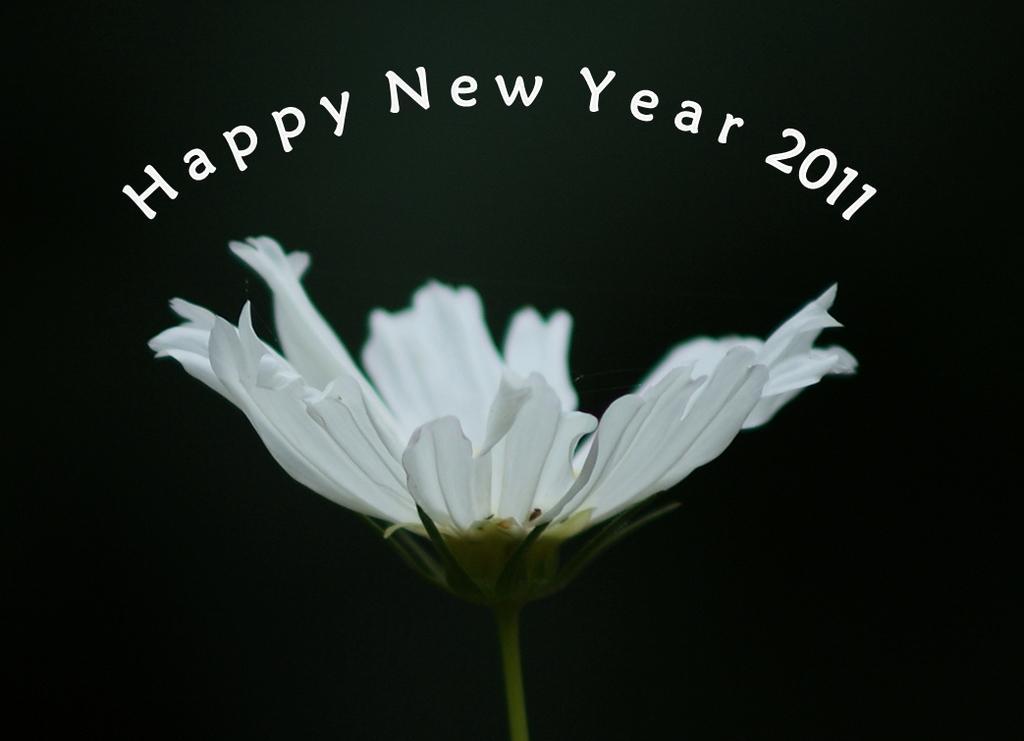Could you give a brief overview of what you see in this image? There is a flower with a black background and there are new year wishes written above the flower of the year 2011. 